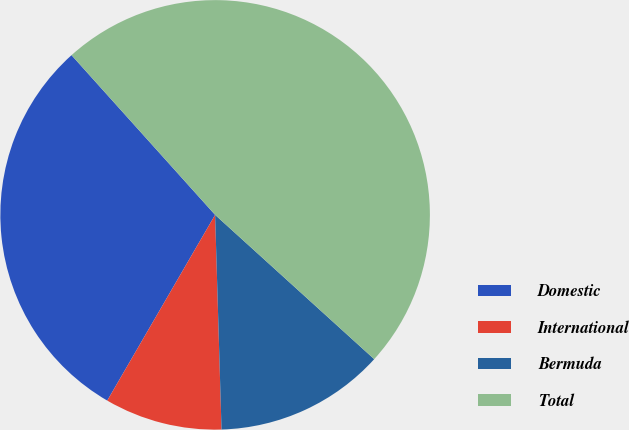Convert chart to OTSL. <chart><loc_0><loc_0><loc_500><loc_500><pie_chart><fcel>Domestic<fcel>International<fcel>Bermuda<fcel>Total<nl><fcel>29.97%<fcel>8.85%<fcel>12.8%<fcel>48.38%<nl></chart> 